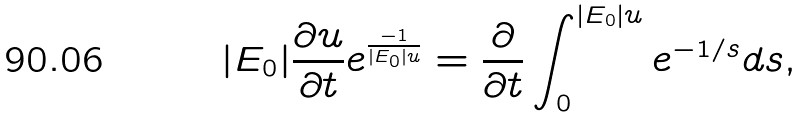<formula> <loc_0><loc_0><loc_500><loc_500>| { E } _ { 0 } | \frac { \partial u } { \partial t } e ^ { \frac { - 1 } { | { E } _ { 0 } | u } } = \frac { \partial } { \partial t } \int _ { 0 } ^ { | { E } _ { 0 } | u } e ^ { - 1 / s } d s ,</formula> 